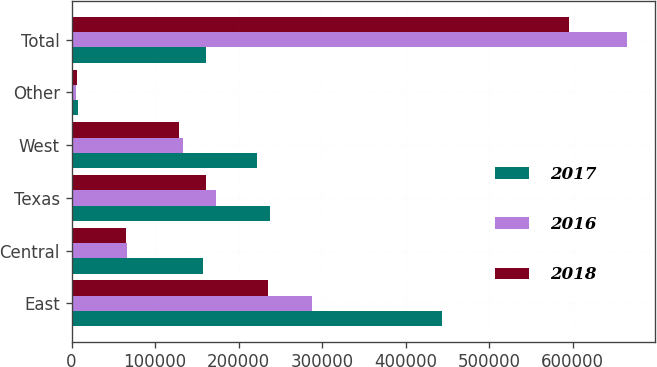<chart> <loc_0><loc_0><loc_500><loc_500><stacked_bar_chart><ecel><fcel>East<fcel>Central<fcel>Texas<fcel>West<fcel>Other<fcel>Total<nl><fcel>2017<fcel>444122<fcel>157420<fcel>237703<fcel>222684<fcel>8195<fcel>160950<nl><fcel>2016<fcel>288138<fcel>66554<fcel>173005<fcel>132920<fcel>5122<fcel>665739<nl><fcel>2018<fcel>235377<fcel>64856<fcel>160950<fcel>128761<fcel>6355<fcel>596299<nl></chart> 